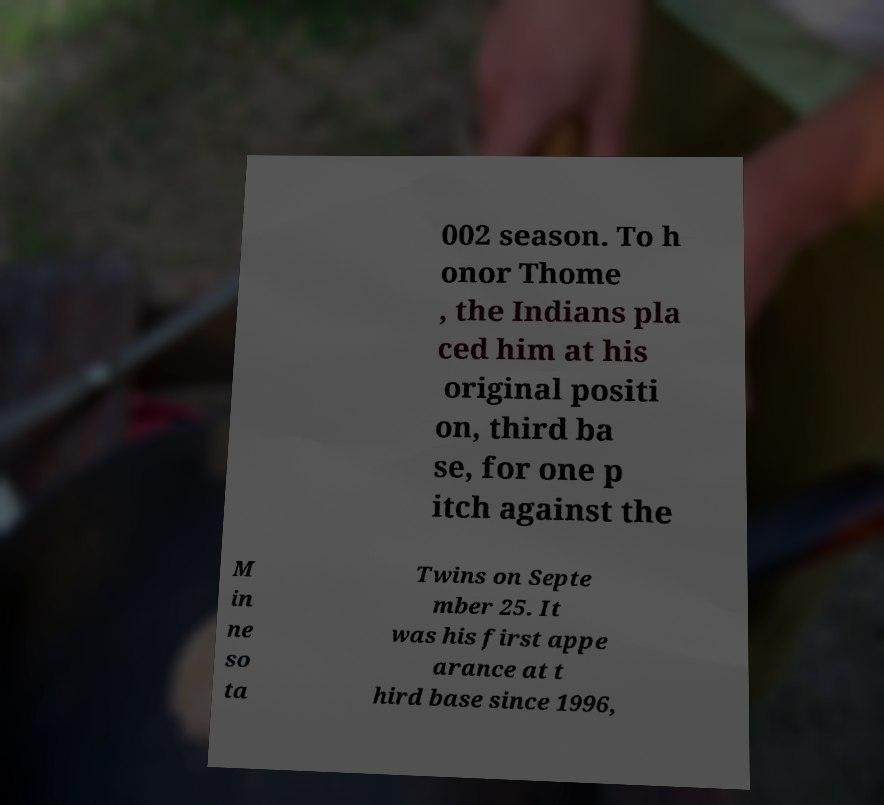Please identify and transcribe the text found in this image. 002 season. To h onor Thome , the Indians pla ced him at his original positi on, third ba se, for one p itch against the M in ne so ta Twins on Septe mber 25. It was his first appe arance at t hird base since 1996, 